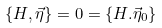<formula> <loc_0><loc_0><loc_500><loc_500>\{ H , \vec { \eta } \} = 0 = \{ H . \vec { \eta } _ { 0 } \}</formula> 